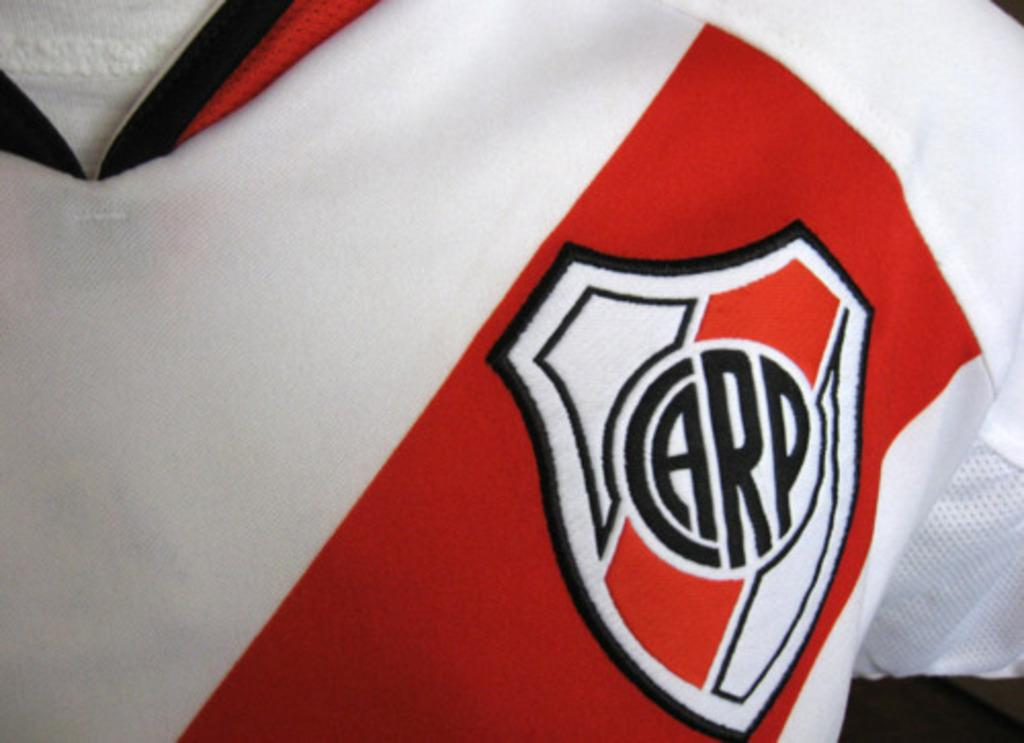<image>
Summarize the visual content of the image. Red and white shirt which says the word CARP on it. 